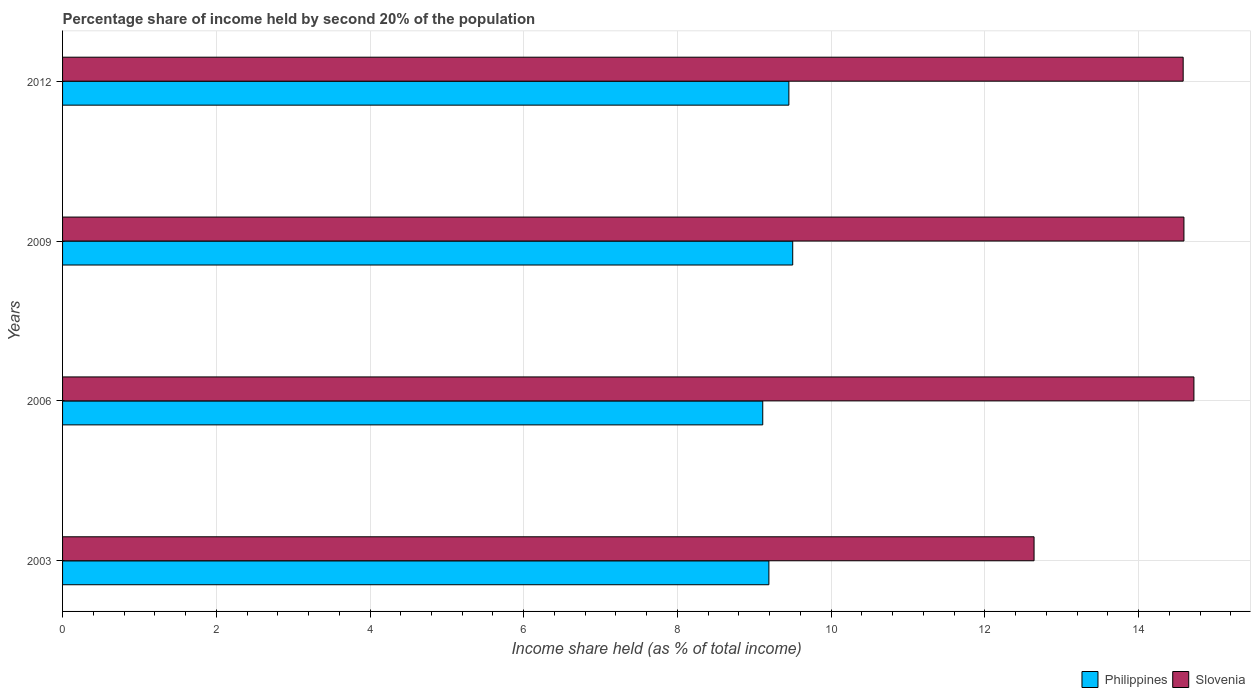How many groups of bars are there?
Keep it short and to the point. 4. Are the number of bars per tick equal to the number of legend labels?
Offer a terse response. Yes. How many bars are there on the 3rd tick from the bottom?
Give a very brief answer. 2. What is the label of the 2nd group of bars from the top?
Offer a terse response. 2009. What is the share of income held by second 20% of the population in Slovenia in 2009?
Make the answer very short. 14.59. Across all years, what is the minimum share of income held by second 20% of the population in Philippines?
Your answer should be very brief. 9.11. In which year was the share of income held by second 20% of the population in Slovenia minimum?
Give a very brief answer. 2003. What is the total share of income held by second 20% of the population in Philippines in the graph?
Provide a short and direct response. 37.25. What is the difference between the share of income held by second 20% of the population in Philippines in 2003 and that in 2009?
Your answer should be very brief. -0.31. What is the difference between the share of income held by second 20% of the population in Slovenia in 2006 and the share of income held by second 20% of the population in Philippines in 2012?
Your answer should be compact. 5.27. What is the average share of income held by second 20% of the population in Slovenia per year?
Offer a terse response. 14.13. In the year 2006, what is the difference between the share of income held by second 20% of the population in Philippines and share of income held by second 20% of the population in Slovenia?
Give a very brief answer. -5.61. What is the ratio of the share of income held by second 20% of the population in Philippines in 2003 to that in 2012?
Your answer should be compact. 0.97. What is the difference between the highest and the second highest share of income held by second 20% of the population in Slovenia?
Provide a succinct answer. 0.13. What is the difference between the highest and the lowest share of income held by second 20% of the population in Slovenia?
Make the answer very short. 2.08. Is the sum of the share of income held by second 20% of the population in Slovenia in 2006 and 2012 greater than the maximum share of income held by second 20% of the population in Philippines across all years?
Your response must be concise. Yes. What does the 1st bar from the top in 2012 represents?
Offer a terse response. Slovenia. How many years are there in the graph?
Offer a very short reply. 4. What is the difference between two consecutive major ticks on the X-axis?
Give a very brief answer. 2. Are the values on the major ticks of X-axis written in scientific E-notation?
Your answer should be very brief. No. How are the legend labels stacked?
Offer a terse response. Horizontal. What is the title of the graph?
Make the answer very short. Percentage share of income held by second 20% of the population. What is the label or title of the X-axis?
Offer a very short reply. Income share held (as % of total income). What is the Income share held (as % of total income) of Philippines in 2003?
Provide a succinct answer. 9.19. What is the Income share held (as % of total income) of Slovenia in 2003?
Your answer should be very brief. 12.64. What is the Income share held (as % of total income) in Philippines in 2006?
Your response must be concise. 9.11. What is the Income share held (as % of total income) of Slovenia in 2006?
Ensure brevity in your answer.  14.72. What is the Income share held (as % of total income) in Philippines in 2009?
Your answer should be very brief. 9.5. What is the Income share held (as % of total income) of Slovenia in 2009?
Make the answer very short. 14.59. What is the Income share held (as % of total income) in Philippines in 2012?
Offer a terse response. 9.45. What is the Income share held (as % of total income) of Slovenia in 2012?
Your answer should be very brief. 14.58. Across all years, what is the maximum Income share held (as % of total income) in Slovenia?
Offer a terse response. 14.72. Across all years, what is the minimum Income share held (as % of total income) of Philippines?
Your response must be concise. 9.11. Across all years, what is the minimum Income share held (as % of total income) in Slovenia?
Ensure brevity in your answer.  12.64. What is the total Income share held (as % of total income) of Philippines in the graph?
Keep it short and to the point. 37.25. What is the total Income share held (as % of total income) of Slovenia in the graph?
Make the answer very short. 56.53. What is the difference between the Income share held (as % of total income) of Slovenia in 2003 and that in 2006?
Make the answer very short. -2.08. What is the difference between the Income share held (as % of total income) of Philippines in 2003 and that in 2009?
Your response must be concise. -0.31. What is the difference between the Income share held (as % of total income) of Slovenia in 2003 and that in 2009?
Give a very brief answer. -1.95. What is the difference between the Income share held (as % of total income) of Philippines in 2003 and that in 2012?
Offer a terse response. -0.26. What is the difference between the Income share held (as % of total income) of Slovenia in 2003 and that in 2012?
Provide a succinct answer. -1.94. What is the difference between the Income share held (as % of total income) in Philippines in 2006 and that in 2009?
Offer a terse response. -0.39. What is the difference between the Income share held (as % of total income) in Slovenia in 2006 and that in 2009?
Offer a terse response. 0.13. What is the difference between the Income share held (as % of total income) in Philippines in 2006 and that in 2012?
Provide a succinct answer. -0.34. What is the difference between the Income share held (as % of total income) in Slovenia in 2006 and that in 2012?
Keep it short and to the point. 0.14. What is the difference between the Income share held (as % of total income) of Philippines in 2009 and that in 2012?
Give a very brief answer. 0.05. What is the difference between the Income share held (as % of total income) of Philippines in 2003 and the Income share held (as % of total income) of Slovenia in 2006?
Ensure brevity in your answer.  -5.53. What is the difference between the Income share held (as % of total income) in Philippines in 2003 and the Income share held (as % of total income) in Slovenia in 2009?
Your response must be concise. -5.4. What is the difference between the Income share held (as % of total income) of Philippines in 2003 and the Income share held (as % of total income) of Slovenia in 2012?
Your answer should be very brief. -5.39. What is the difference between the Income share held (as % of total income) of Philippines in 2006 and the Income share held (as % of total income) of Slovenia in 2009?
Your response must be concise. -5.48. What is the difference between the Income share held (as % of total income) in Philippines in 2006 and the Income share held (as % of total income) in Slovenia in 2012?
Make the answer very short. -5.47. What is the difference between the Income share held (as % of total income) of Philippines in 2009 and the Income share held (as % of total income) of Slovenia in 2012?
Make the answer very short. -5.08. What is the average Income share held (as % of total income) of Philippines per year?
Ensure brevity in your answer.  9.31. What is the average Income share held (as % of total income) of Slovenia per year?
Your answer should be compact. 14.13. In the year 2003, what is the difference between the Income share held (as % of total income) of Philippines and Income share held (as % of total income) of Slovenia?
Make the answer very short. -3.45. In the year 2006, what is the difference between the Income share held (as % of total income) in Philippines and Income share held (as % of total income) in Slovenia?
Provide a short and direct response. -5.61. In the year 2009, what is the difference between the Income share held (as % of total income) in Philippines and Income share held (as % of total income) in Slovenia?
Provide a succinct answer. -5.09. In the year 2012, what is the difference between the Income share held (as % of total income) of Philippines and Income share held (as % of total income) of Slovenia?
Your response must be concise. -5.13. What is the ratio of the Income share held (as % of total income) of Philippines in 2003 to that in 2006?
Provide a short and direct response. 1.01. What is the ratio of the Income share held (as % of total income) in Slovenia in 2003 to that in 2006?
Offer a very short reply. 0.86. What is the ratio of the Income share held (as % of total income) of Philippines in 2003 to that in 2009?
Provide a succinct answer. 0.97. What is the ratio of the Income share held (as % of total income) in Slovenia in 2003 to that in 2009?
Your answer should be very brief. 0.87. What is the ratio of the Income share held (as % of total income) of Philippines in 2003 to that in 2012?
Offer a terse response. 0.97. What is the ratio of the Income share held (as % of total income) of Slovenia in 2003 to that in 2012?
Offer a terse response. 0.87. What is the ratio of the Income share held (as % of total income) of Philippines in 2006 to that in 2009?
Make the answer very short. 0.96. What is the ratio of the Income share held (as % of total income) in Slovenia in 2006 to that in 2009?
Your answer should be compact. 1.01. What is the ratio of the Income share held (as % of total income) in Slovenia in 2006 to that in 2012?
Your answer should be very brief. 1.01. What is the difference between the highest and the second highest Income share held (as % of total income) of Slovenia?
Offer a terse response. 0.13. What is the difference between the highest and the lowest Income share held (as % of total income) in Philippines?
Make the answer very short. 0.39. What is the difference between the highest and the lowest Income share held (as % of total income) of Slovenia?
Keep it short and to the point. 2.08. 